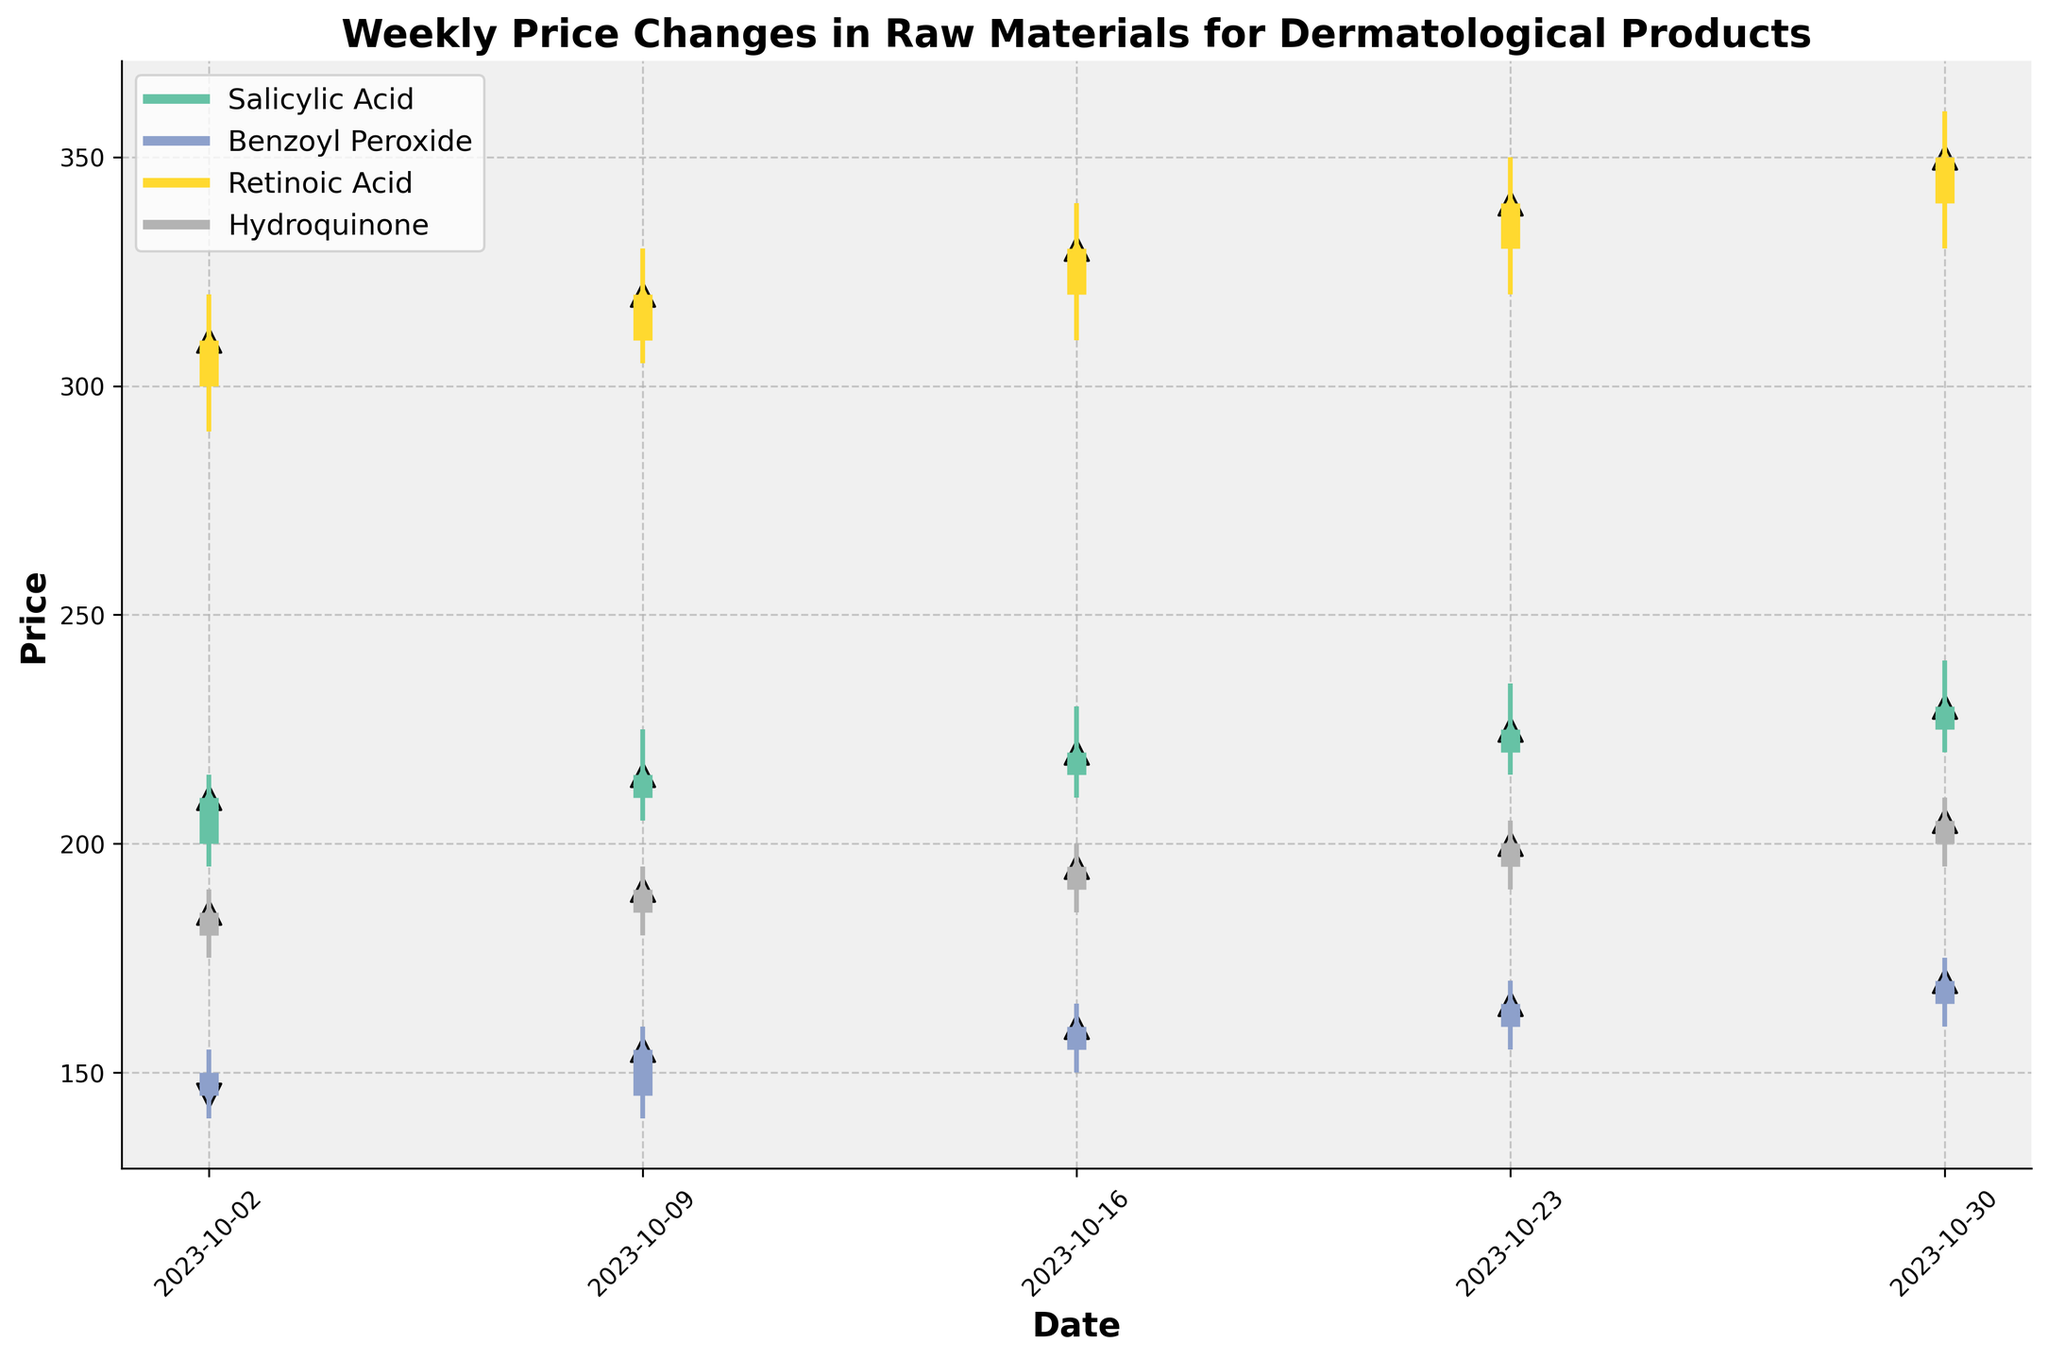What is the title of the plot? The title is located at the top of the plot and provides a summary of what the plot represents.
Answer: Weekly Price Changes in Raw Materials for Dermatological Products Which material has the highest closing price on October 23, 2023? To find this, identify the 'Close' prices for all materials on October 23, 2023, and select the highest value. Retinoic Acid closes at 340, the highest among the materials.
Answer: Retinoic Acid How many materials are shown in the plot? The unique materials can be seen in the legend or by counting distinct colors in the plot. There are four distinct materials represented.
Answer: 4 Did Salicylic Acid price always close higher than it opened each week? Check each week for Salicylic Acid to see if the 'Close' price is greater than the 'Open' price. For each week from October 2 to October 30, 2023, the closing price for Salicylic Acid is greater than or equal to the opening price.
Answer: Yes Which material shows the largest price range (High-Low) on October 16, 2023? Calculate the price range for each material on October 16, 2023. Retinoic Acid has the highest range with High=340 and Low=310, giving a range of 30.
Answer: Retinoic Acid Between October 2 and October 30, which material had the largest increase in closing price? Subtract the opening 'Close' value from the closing 'Close' value for each material and compare. Salicylic Acid increased from 210 to 230.
Answer: Salicylic Acid What is the exact closing price of Hydroquinone on October 9, 2023? Locate the closing price for Hydroquinone on October 9, 2023 from the plot. It is 190.
Answer: 190 By how much did Benzoyl Peroxide's closing price change from October 2, 2023 to October 30, 2023? Subtract the closing price of Benzoyl Peroxide on October 2 (145) from the closing price on October 30 (170). The change is 25.
Answer: 25 Which date shows the highest volatility for all materials? Measure volatility by the length of the vertical lines (High-Low) for all materials on each date. October 30, 2023 has the highest overall range in price movements.
Answer: October 30, 2023 On which date did all materials close higher than they opened? Check the 'Open' and 'Close' prices for all materials on each date and ensure all materials closed higher. On October 16, 2023, all materials meet this criterion.
Answer: October 16, 2023 